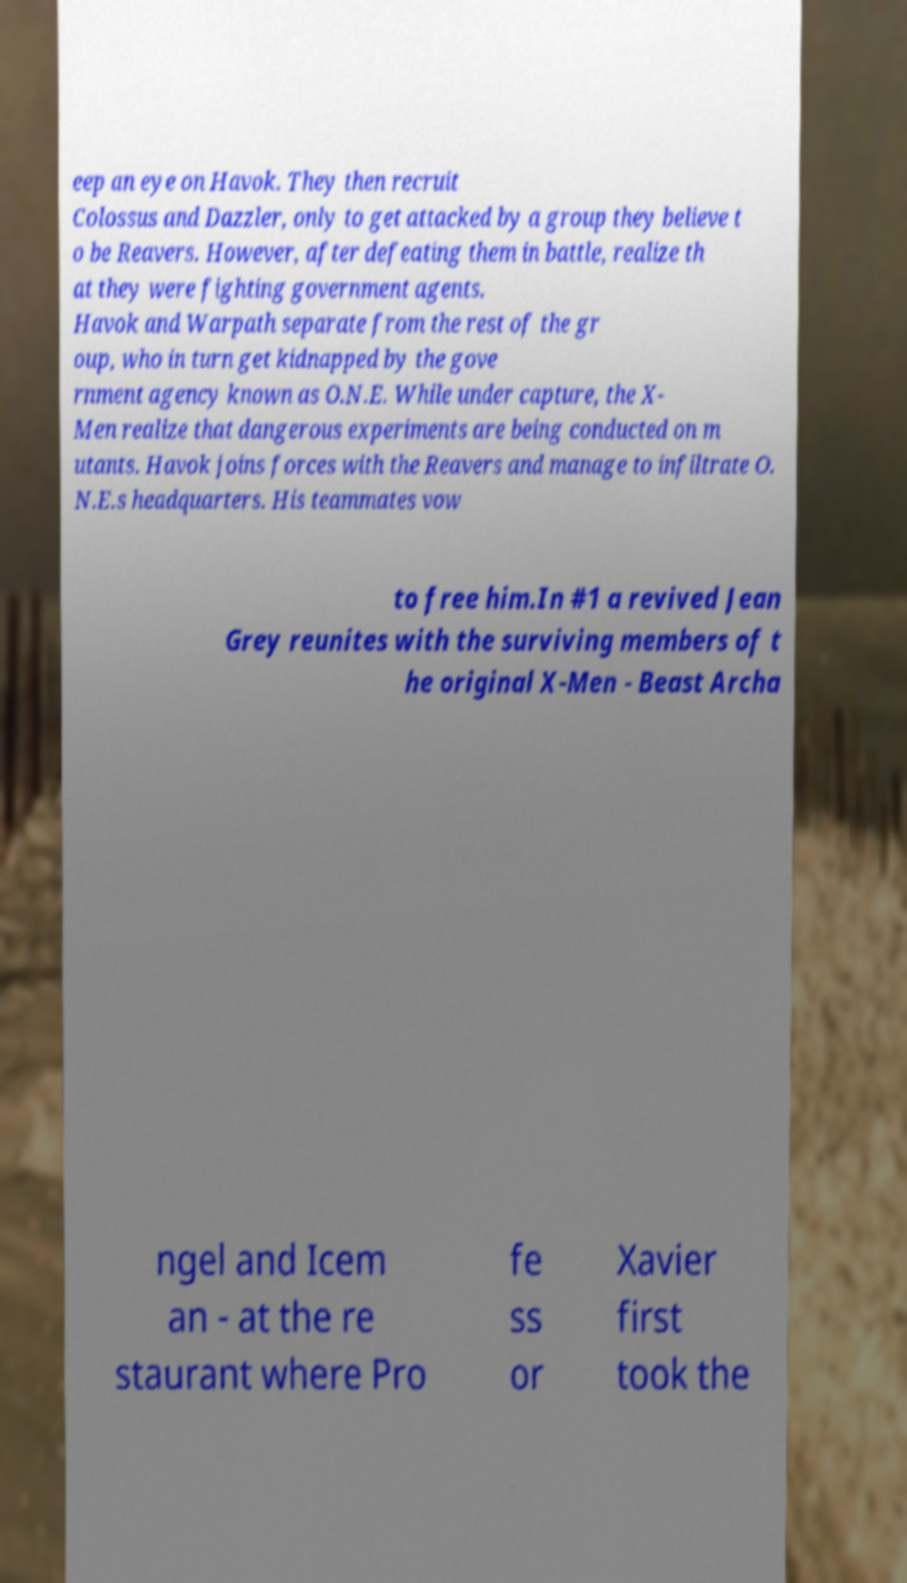What messages or text are displayed in this image? I need them in a readable, typed format. eep an eye on Havok. They then recruit Colossus and Dazzler, only to get attacked by a group they believe t o be Reavers. However, after defeating them in battle, realize th at they were fighting government agents. Havok and Warpath separate from the rest of the gr oup, who in turn get kidnapped by the gove rnment agency known as O.N.E. While under capture, the X- Men realize that dangerous experiments are being conducted on m utants. Havok joins forces with the Reavers and manage to infiltrate O. N.E.s headquarters. His teammates vow to free him.In #1 a revived Jean Grey reunites with the surviving members of t he original X-Men - Beast Archa ngel and Icem an - at the re staurant where Pro fe ss or Xavier first took the 